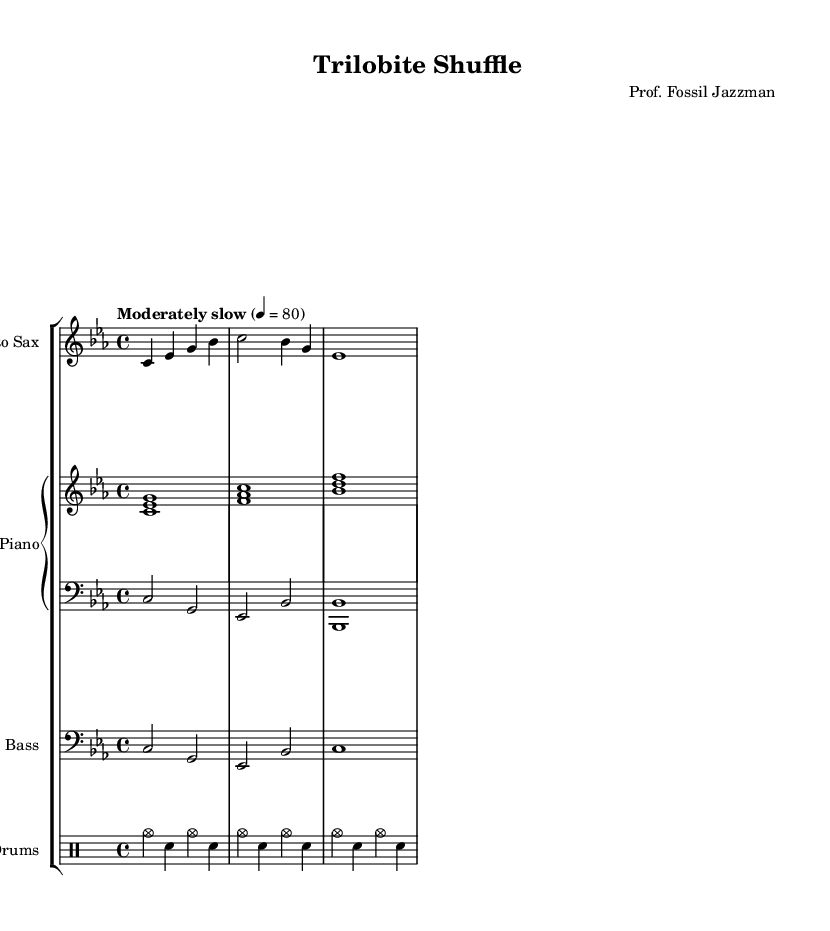What is the key signature of this music? The key signature is C minor, which has three flats (B♭, E♭, and A♭). This can be identified from the initial part of the music.
Answer: C minor What is the time signature of this piece? The time signature is found at the beginning of the sheet music, indicated as 4/4, which means four beats per measure.
Answer: 4/4 What is the tempo marking for the piece? The tempo marking states "Moderately slow," and is specified at the beginning with a metronome marking of 80 beats per minute. This guides the performance speed.
Answer: Moderately slow What is the instrument designated for the main melody? The main melodic instrument is indicated as "Alto Sax" at the beginning of the staff group, representing the primary voice of this composition.
Answer: Alto Sax How many measures are present in the saxophone part? Counting the measures in the saxophone part shows there are three measures, as indicated by the division of measures by vertical lines.
Answer: 3 What type of jazz piece is being represented in this sheet music? The title "Trilobite Shuffle" suggests it is a cool jazz piece, drawing inspiration from fossil discoveries, indicative of a theme linking music with paleontology.
Answer: Cool Jazz How is the rhythm structured for the drums? The drum part consists of a consistent alternating pattern of cymbals and snare notes across three measures, represented in a simple rhythmic structure typical for jazz.
Answer: Alternating pattern 